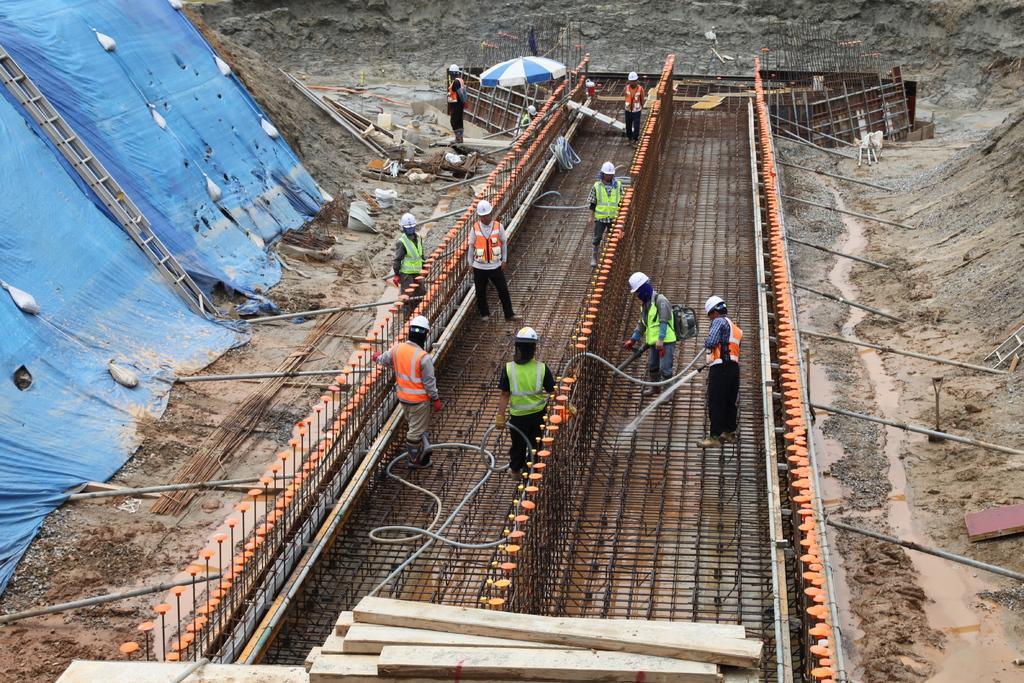Can you describe this image briefly? In this picture I can see the workers who are standing near to the rods. On the left there is a ladder which is kept on this blue carpet. On the right I can see the sand. At the top I can see an umbrella and other objects. At the bottom I can see the wooden rafter. 